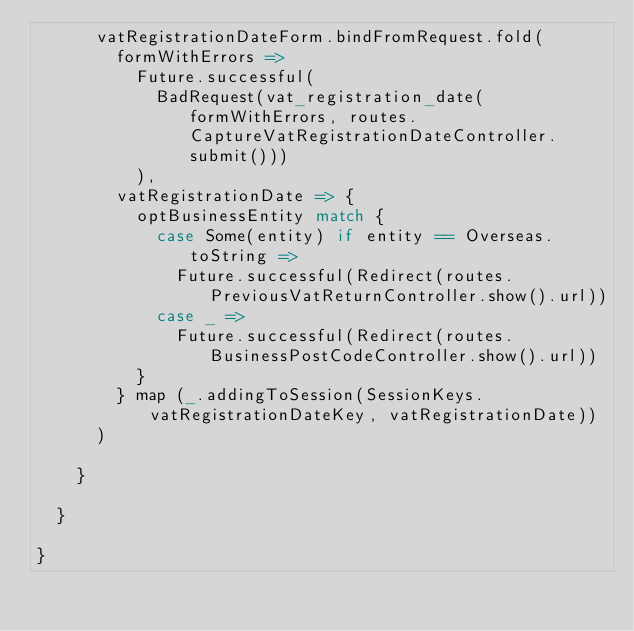Convert code to text. <code><loc_0><loc_0><loc_500><loc_500><_Scala_>      vatRegistrationDateForm.bindFromRequest.fold(
        formWithErrors =>
          Future.successful(
            BadRequest(vat_registration_date(formWithErrors, routes.CaptureVatRegistrationDateController.submit()))
          ),
        vatRegistrationDate => {
          optBusinessEntity match {
            case Some(entity) if entity == Overseas.toString =>
              Future.successful(Redirect(routes.PreviousVatReturnController.show().url))
            case _ =>
              Future.successful(Redirect(routes.BusinessPostCodeController.show().url))
          }
        } map (_.addingToSession(SessionKeys.vatRegistrationDateKey, vatRegistrationDate))
      )

    }

  }

}
</code> 